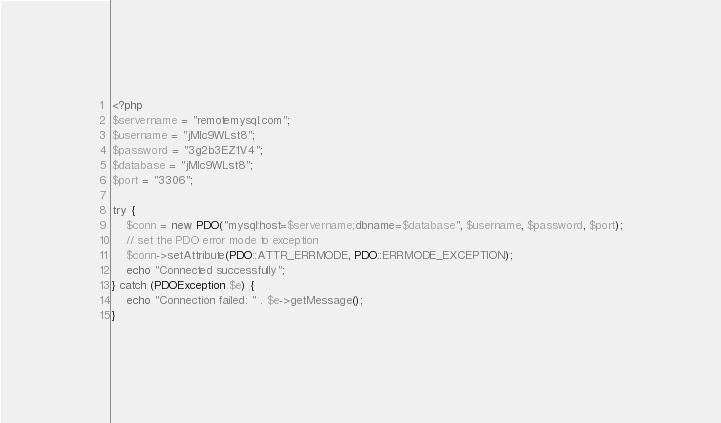<code> <loc_0><loc_0><loc_500><loc_500><_PHP_><?php
$servername = "remotemysql.com";
$username = "jMIc9WLst8";
$password = "3g2b3EZ1V4";
$database = "jMIc9WLst8";
$port = "3306";

try {
    $conn = new PDO("mysql:host=$servername;dbname=$database", $username, $password, $port);
    // set the PDO error mode to exception
    $conn->setAttribute(PDO::ATTR_ERRMODE, PDO::ERRMODE_EXCEPTION);
    echo "Connected successfully";
} catch (PDOException $e) {
    echo "Connection failed: " . $e->getMessage();
}
</code> 